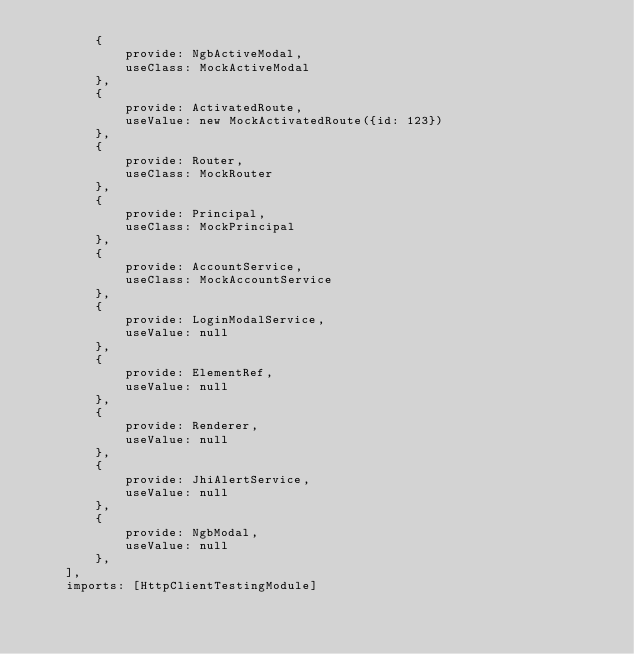Convert code to text. <code><loc_0><loc_0><loc_500><loc_500><_TypeScript_>        {
            provide: NgbActiveModal,
            useClass: MockActiveModal
        },
        {
            provide: ActivatedRoute,
            useValue: new MockActivatedRoute({id: 123})
        },
        {
            provide: Router,
            useClass: MockRouter
        },
        {
            provide: Principal,
            useClass: MockPrincipal
        },
        {
            provide: AccountService,
            useClass: MockAccountService
        },
        {
            provide: LoginModalService,
            useValue: null
        },
        {
            provide: ElementRef,
            useValue: null
        },
        {
            provide: Renderer,
            useValue: null
        },
        {
            provide: JhiAlertService,
            useValue: null
        },
        {
            provide: NgbModal,
            useValue: null
        },
    ],
    imports: [HttpClientTestingModule]</code> 